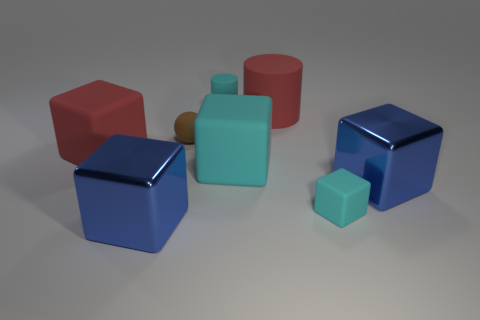There is a cyan cylinder; does it have the same size as the metal object that is on the left side of the small brown matte thing?
Your answer should be very brief. No. Does the cyan rubber block that is on the right side of the red cylinder have the same size as the matte sphere?
Your response must be concise. Yes. What number of other things are made of the same material as the large cyan cube?
Give a very brief answer. 5. Are there an equal number of tiny brown balls on the left side of the matte ball and red matte cubes that are in front of the red matte cube?
Provide a short and direct response. Yes. The big thing in front of the large blue object behind the big blue object that is left of the small matte ball is what color?
Provide a short and direct response. Blue. What is the shape of the tiny cyan object on the left side of the big rubber cylinder?
Provide a short and direct response. Cylinder. There is a small cyan thing that is made of the same material as the small cyan cylinder; what is its shape?
Give a very brief answer. Cube. Is there any other thing that is the same shape as the big cyan matte object?
Offer a terse response. Yes. What number of blue shiny blocks are right of the large cyan matte object?
Offer a terse response. 1. Are there the same number of cyan cylinders that are in front of the large cyan rubber object and big red cylinders?
Make the answer very short. No. 